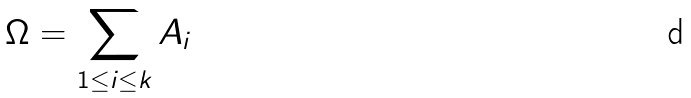<formula> <loc_0><loc_0><loc_500><loc_500>\Omega = \sum _ { 1 \leq i \leq k } A _ { i }</formula> 